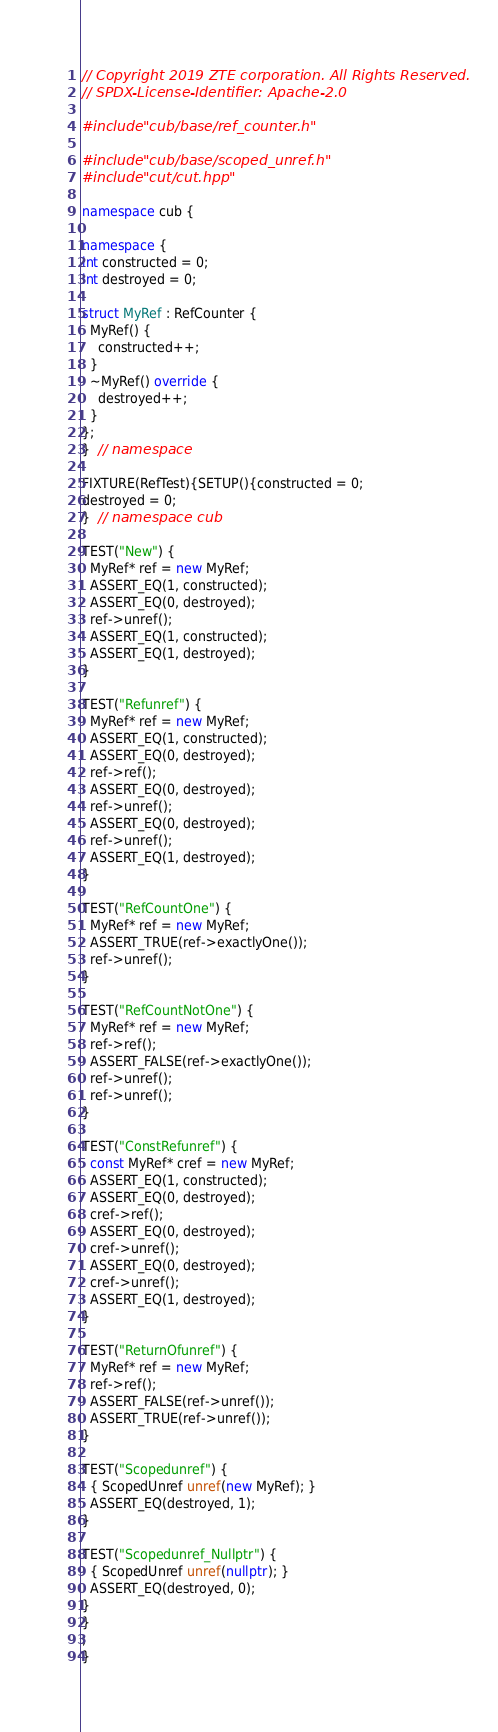Convert code to text. <code><loc_0><loc_0><loc_500><loc_500><_C++_>// Copyright 2019 ZTE corporation. All Rights Reserved.
// SPDX-License-Identifier: Apache-2.0

#include "cub/base/ref_counter.h"

#include "cub/base/scoped_unref.h"
#include "cut/cut.hpp"

namespace cub {

namespace {
int constructed = 0;
int destroyed = 0;

struct MyRef : RefCounter {
  MyRef() {
    constructed++;
  }
  ~MyRef() override {
    destroyed++;
  }
};
}  // namespace

FIXTURE(RefTest){SETUP(){constructed = 0;
destroyed = 0;
}  // namespace cub

TEST("New") {
  MyRef* ref = new MyRef;
  ASSERT_EQ(1, constructed);
  ASSERT_EQ(0, destroyed);
  ref->unref();
  ASSERT_EQ(1, constructed);
  ASSERT_EQ(1, destroyed);
}

TEST("Refunref") {
  MyRef* ref = new MyRef;
  ASSERT_EQ(1, constructed);
  ASSERT_EQ(0, destroyed);
  ref->ref();
  ASSERT_EQ(0, destroyed);
  ref->unref();
  ASSERT_EQ(0, destroyed);
  ref->unref();
  ASSERT_EQ(1, destroyed);
}

TEST("RefCountOne") {
  MyRef* ref = new MyRef;
  ASSERT_TRUE(ref->exactlyOne());
  ref->unref();
}

TEST("RefCountNotOne") {
  MyRef* ref = new MyRef;
  ref->ref();
  ASSERT_FALSE(ref->exactlyOne());
  ref->unref();
  ref->unref();
}

TEST("ConstRefunref") {
  const MyRef* cref = new MyRef;
  ASSERT_EQ(1, constructed);
  ASSERT_EQ(0, destroyed);
  cref->ref();
  ASSERT_EQ(0, destroyed);
  cref->unref();
  ASSERT_EQ(0, destroyed);
  cref->unref();
  ASSERT_EQ(1, destroyed);
}

TEST("ReturnOfunref") {
  MyRef* ref = new MyRef;
  ref->ref();
  ASSERT_FALSE(ref->unref());
  ASSERT_TRUE(ref->unref());
}

TEST("Scopedunref") {
  { ScopedUnref unref(new MyRef); }
  ASSERT_EQ(destroyed, 1);
}

TEST("Scopedunref_Nullptr") {
  { ScopedUnref unref(nullptr); }
  ASSERT_EQ(destroyed, 0);
}
}
;
}
</code> 